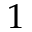Convert formula to latex. <formula><loc_0><loc_0><loc_500><loc_500>1</formula> 